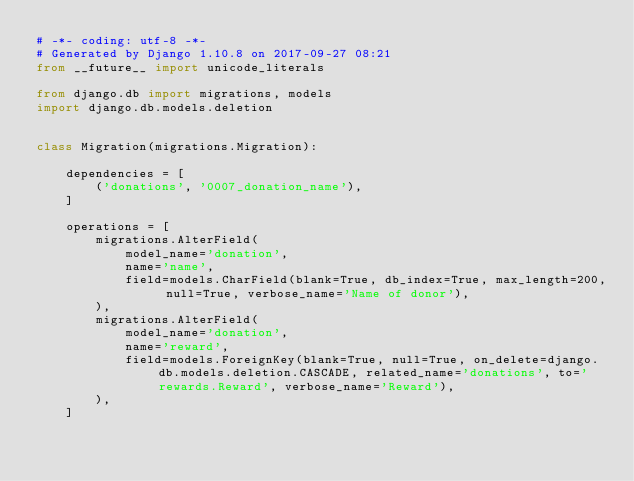<code> <loc_0><loc_0><loc_500><loc_500><_Python_># -*- coding: utf-8 -*-
# Generated by Django 1.10.8 on 2017-09-27 08:21
from __future__ import unicode_literals

from django.db import migrations, models
import django.db.models.deletion


class Migration(migrations.Migration):

    dependencies = [
        ('donations', '0007_donation_name'),
    ]

    operations = [
        migrations.AlterField(
            model_name='donation',
            name='name',
            field=models.CharField(blank=True, db_index=True, max_length=200, null=True, verbose_name='Name of donor'),
        ),
        migrations.AlterField(
            model_name='donation',
            name='reward',
            field=models.ForeignKey(blank=True, null=True, on_delete=django.db.models.deletion.CASCADE, related_name='donations', to='rewards.Reward', verbose_name='Reward'),
        ),
    ]
</code> 